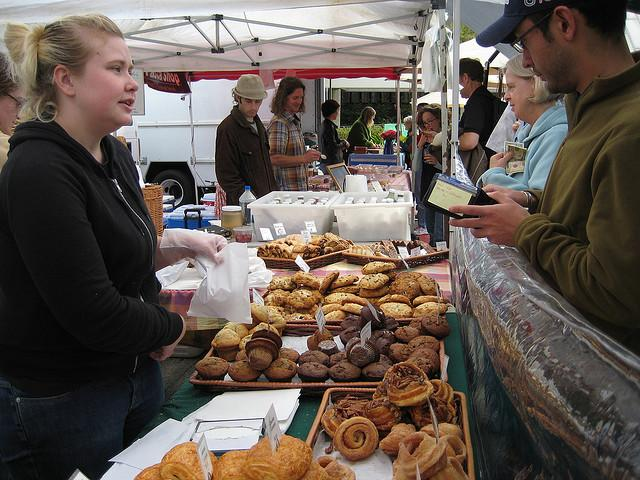Why is the woman on the left standing behind the table of pastries? selling them 